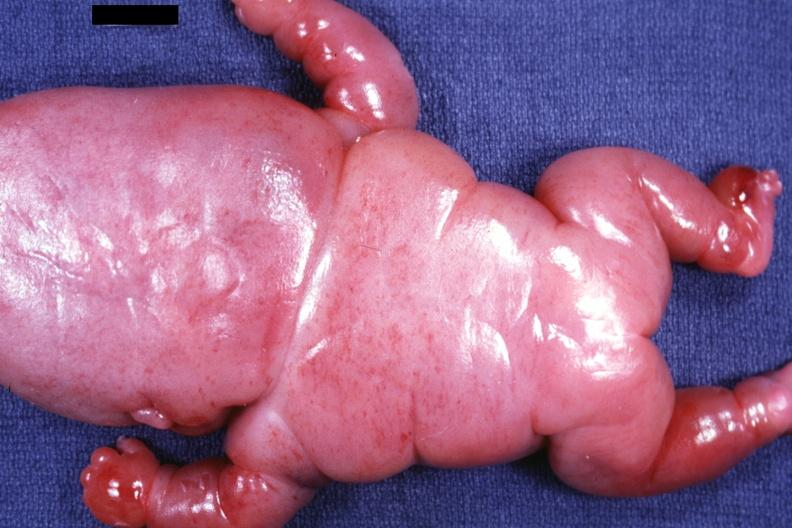what does this image show?
Answer the question using a single word or phrase. Posterior view of body lesions mostly in head neck and thorax 